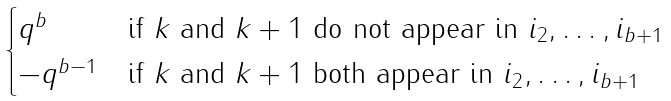Convert formula to latex. <formula><loc_0><loc_0><loc_500><loc_500>\begin{cases} q ^ { b } & \text {if $k$ and $k+1$ do not appear in $i_{2}, \dots, i_{b+1}$} \\ - q ^ { b - 1 } & \text {if $k$ and $k+1$ both appear in $i_{2}, \dots, i_{b+1}$} \\ \end{cases}</formula> 